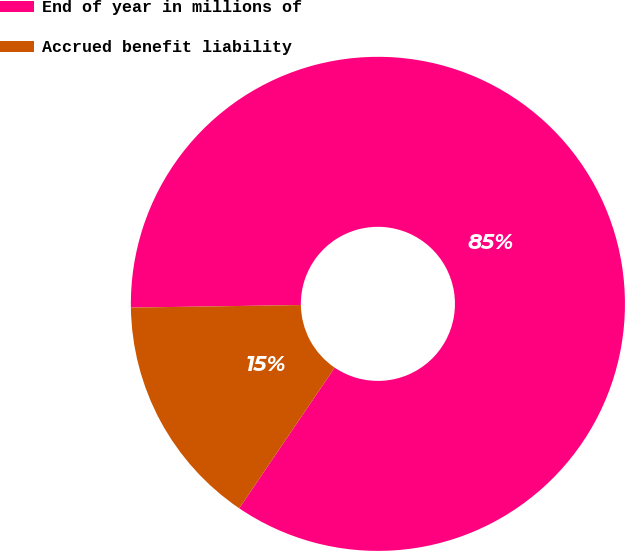Convert chart. <chart><loc_0><loc_0><loc_500><loc_500><pie_chart><fcel>End of year in millions of<fcel>Accrued benefit liability<nl><fcel>84.73%<fcel>15.27%<nl></chart> 